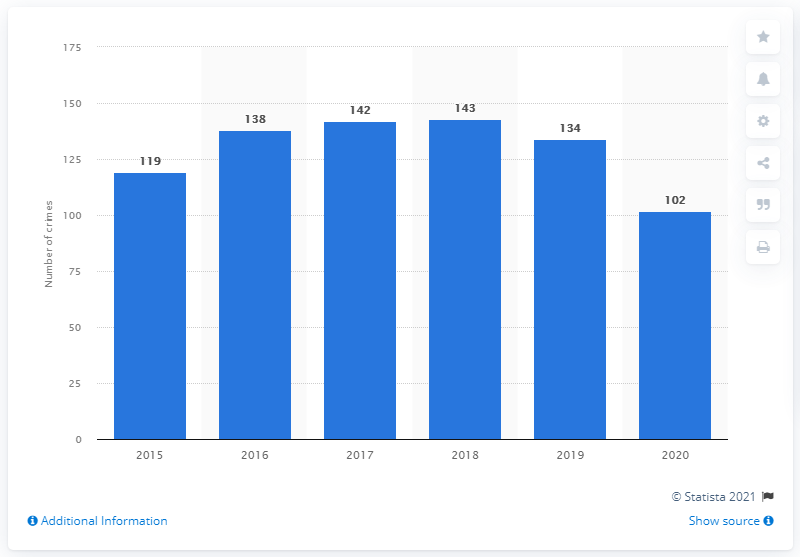Point out several critical features in this image. In 2020, there were 102 reported murders in the country of Belize. In 2019, a total of 134 murders were reported to the Belizean police. 